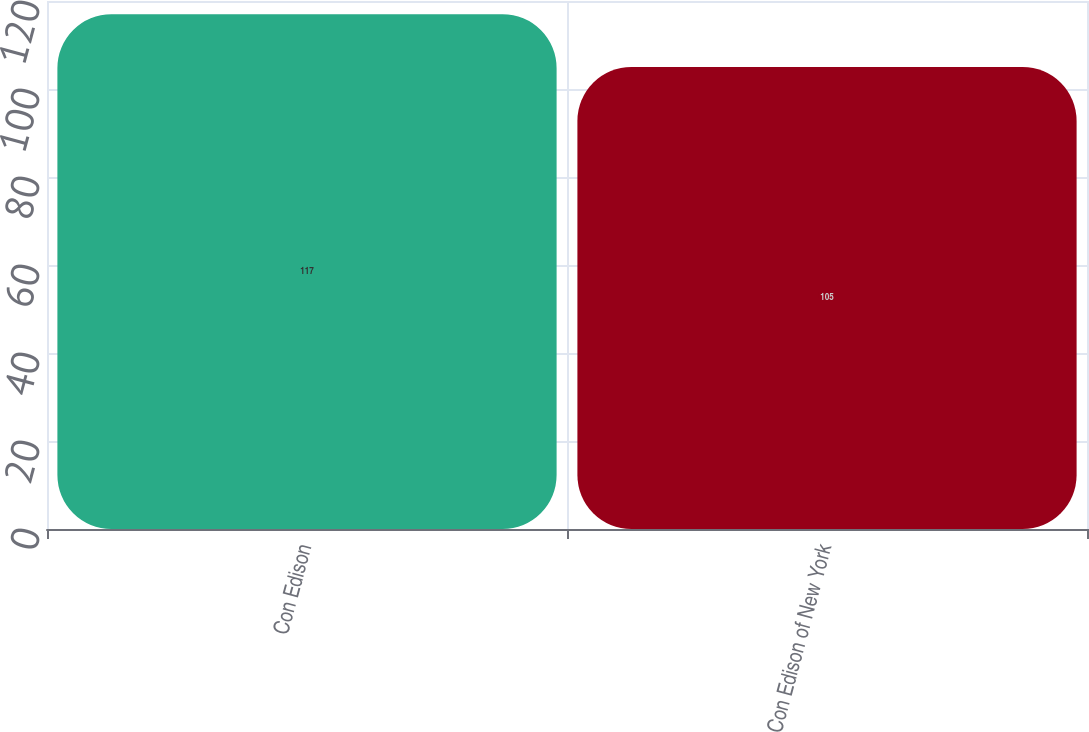<chart> <loc_0><loc_0><loc_500><loc_500><bar_chart><fcel>Con Edison<fcel>Con Edison of New York<nl><fcel>117<fcel>105<nl></chart> 